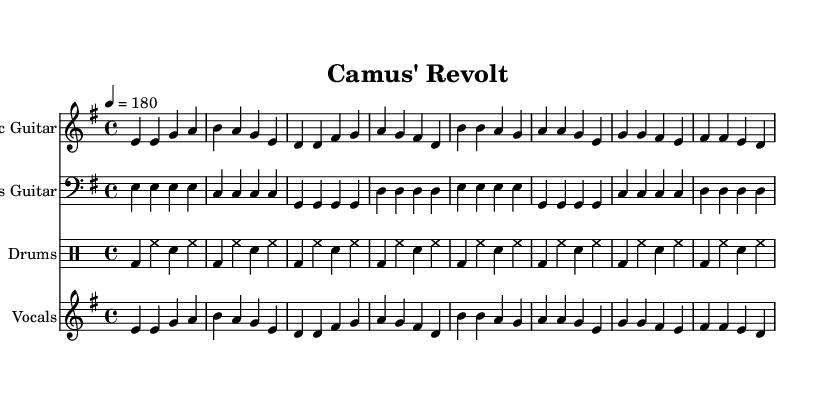What is the key signature of this music? The key signature of the music is indicated by the symbol before the notes. In this case, there is one sharp sign, which signifies E minor.
Answer: E minor What is the time signature of the music? The time signature is located at the beginning of the staff and is written in the form of two numbers. Here, it shows a 4 above a 4, meaning the music is in 4/4 time.
Answer: 4/4 What is the tempo of the piece? The tempo is indicated by the marking provided at the beginning of the music, which is set at a quarter note equals 180 beats per minute, indicating a brisk pace.
Answer: 180 How many measures are in the verse section? To determine this, we need to count the measures in the verse portion of the music. The verse section consists of four measures as indicated in the notation.
Answer: 4 What is the primary instrument used in the vocal part? The vocal part is clearly labeled and suggests that it is meant for vocals. It is characterized as a singing part in this piece.
Answer: Vocals What is the pattern of the drum beat in this piece? The drum pattern consists of a standard punk beat, which follows a consistent kick-drum and snare alternation throughout, creating a driving rhythm typical of punk music.
Answer: Standard punk beat What chord progression can be inferred from the verse section? The verse section is based on a specific sequence of notes that corresponds to a familiar punk rock progression. Analyzing the notes, we can identify the progression aligning with common punk signatures.
Answer: E minor, D major, G major, A major 